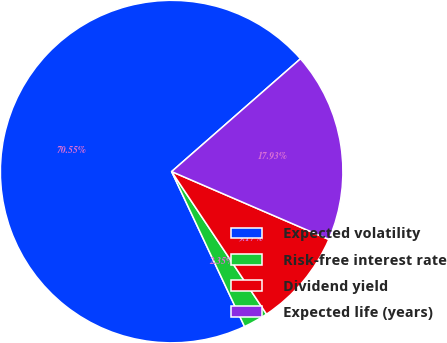<chart> <loc_0><loc_0><loc_500><loc_500><pie_chart><fcel>Expected volatility<fcel>Risk-free interest rate<fcel>Dividend yield<fcel>Expected life (years)<nl><fcel>70.55%<fcel>2.35%<fcel>9.17%<fcel>17.93%<nl></chart> 